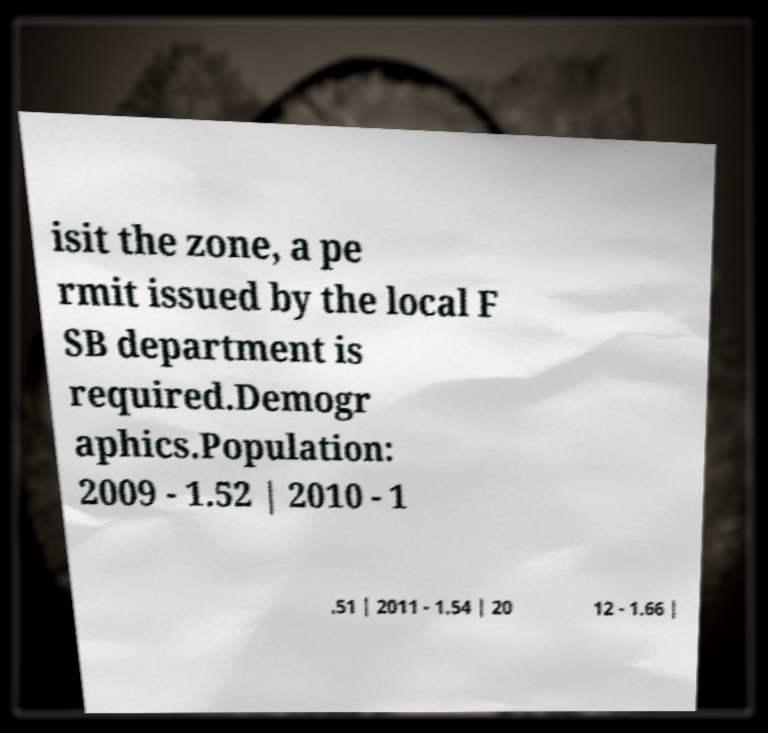For documentation purposes, I need the text within this image transcribed. Could you provide that? isit the zone, a pe rmit issued by the local F SB department is required.Demogr aphics.Population: 2009 - 1.52 | 2010 - 1 .51 | 2011 - 1.54 | 20 12 - 1.66 | 